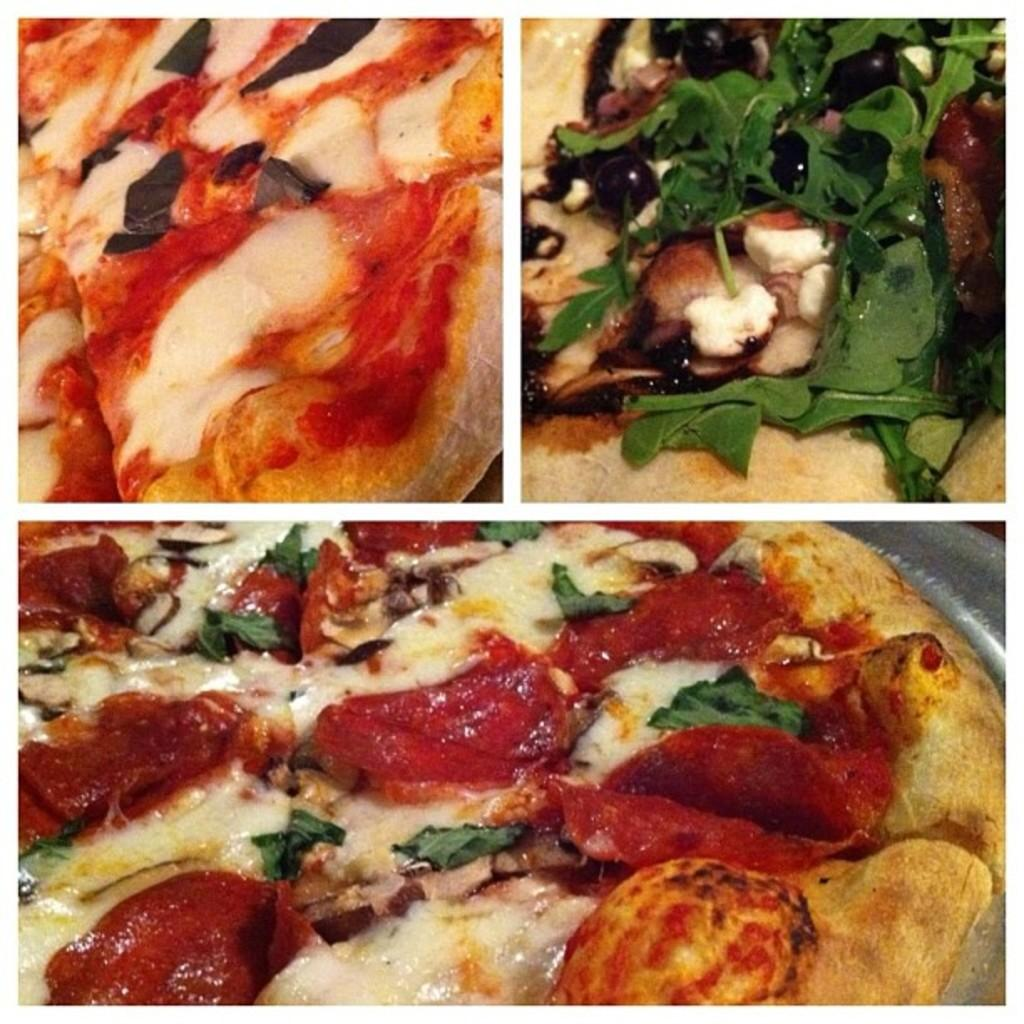What type of artwork is depicted in the image? The image is a collage. What is the main subject of the collage? The main subject of the collage is pizza, as there are two pizza images present. Where is one of the pizza images located in the collage? One of the pizza images is at the bottom of the collage. Where is the other pizza image located in the collage? The other pizza image is at the top of the collage. What type of canvas is used for the collage in the image? The image does not show the canvas or material used for the collage; it only shows the collage itself. 